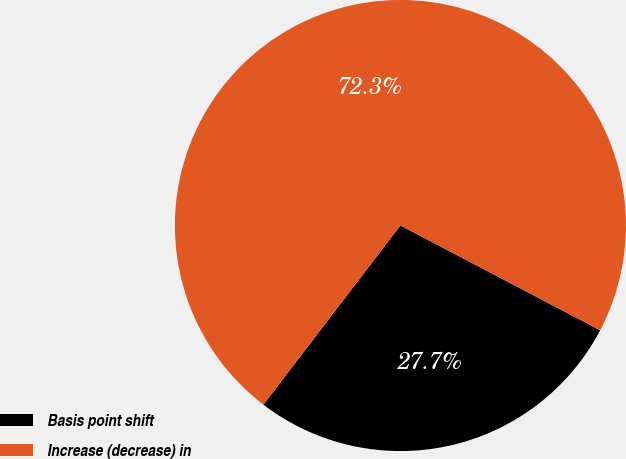Convert chart. <chart><loc_0><loc_0><loc_500><loc_500><pie_chart><fcel>Basis point shift<fcel>Increase (decrease) in<nl><fcel>27.7%<fcel>72.3%<nl></chart> 